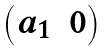<formula> <loc_0><loc_0><loc_500><loc_500>\begin{pmatrix} a _ { 1 } & 0 \end{pmatrix}</formula> 